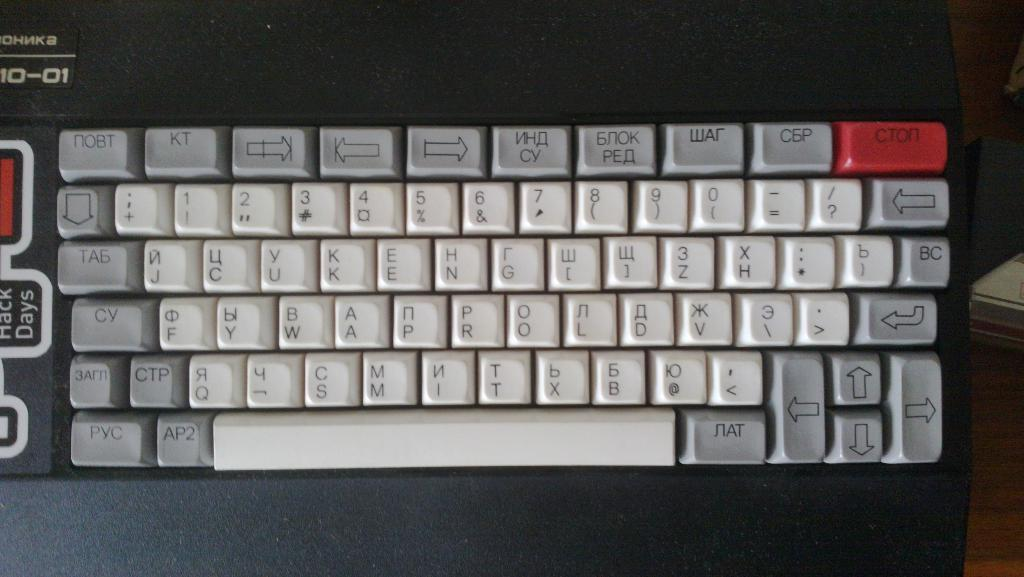<image>
Give a short and clear explanation of the subsequent image. Ohnka keyboard that is black, white, gray, and red 